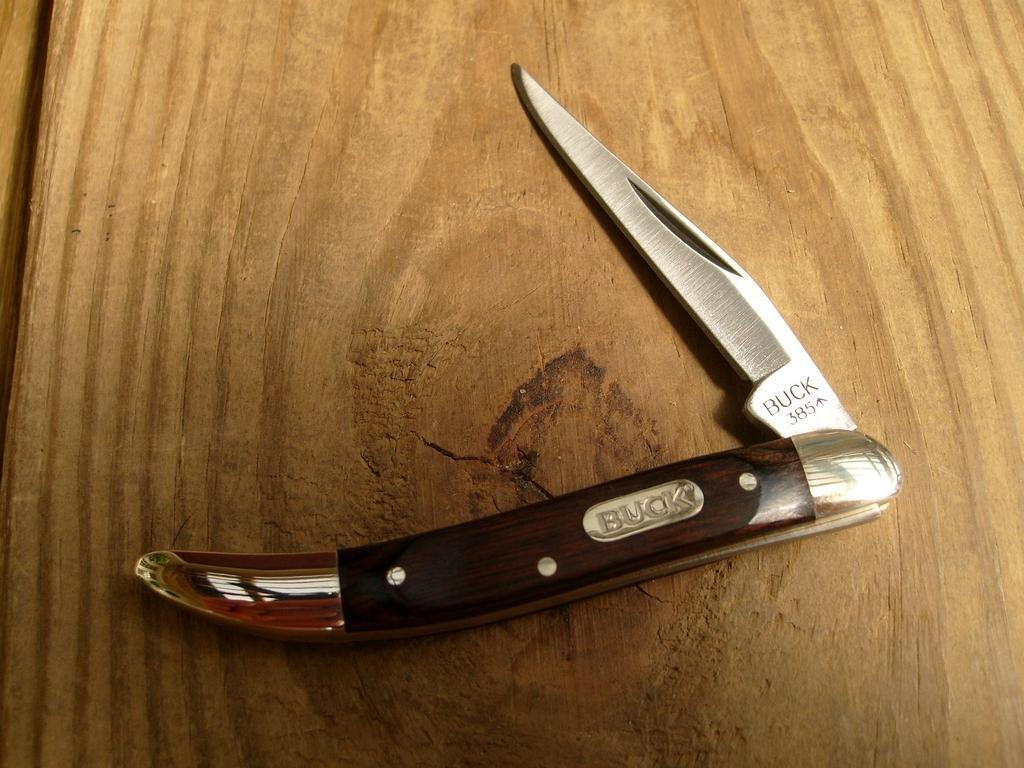Describe this image in one or two sentences. On the wooden surface we can see utility knife. 